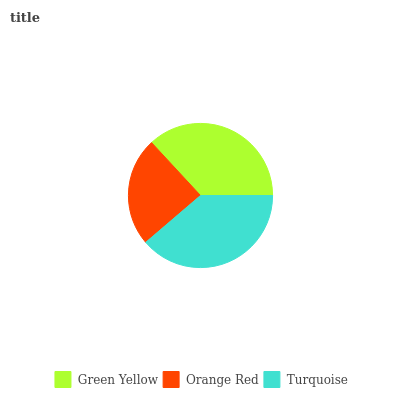Is Orange Red the minimum?
Answer yes or no. Yes. Is Turquoise the maximum?
Answer yes or no. Yes. Is Turquoise the minimum?
Answer yes or no. No. Is Orange Red the maximum?
Answer yes or no. No. Is Turquoise greater than Orange Red?
Answer yes or no. Yes. Is Orange Red less than Turquoise?
Answer yes or no. Yes. Is Orange Red greater than Turquoise?
Answer yes or no. No. Is Turquoise less than Orange Red?
Answer yes or no. No. Is Green Yellow the high median?
Answer yes or no. Yes. Is Green Yellow the low median?
Answer yes or no. Yes. Is Orange Red the high median?
Answer yes or no. No. Is Orange Red the low median?
Answer yes or no. No. 